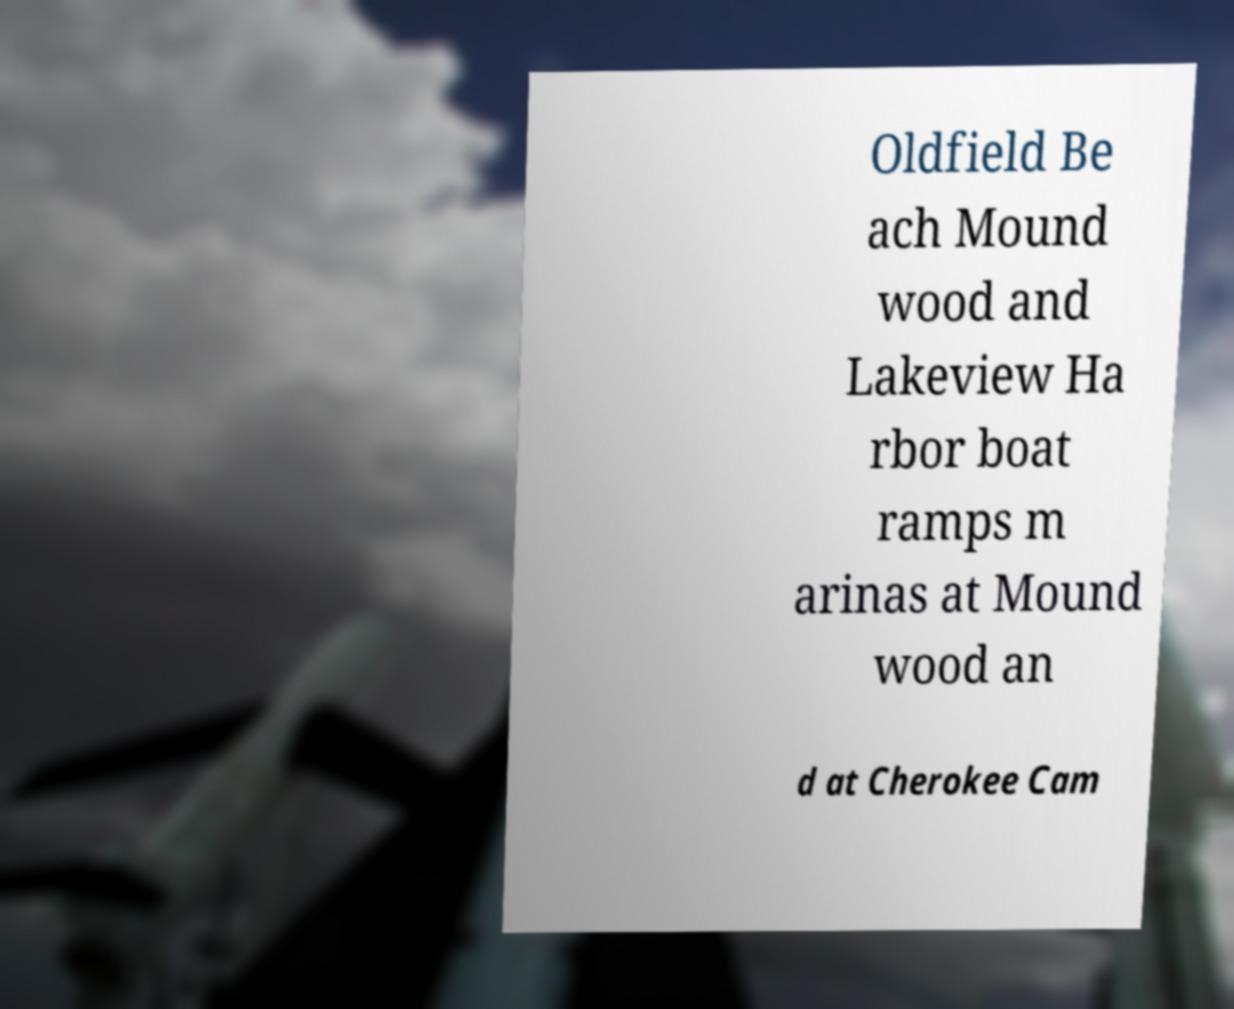Could you extract and type out the text from this image? Oldfield Be ach Mound wood and Lakeview Ha rbor boat ramps m arinas at Mound wood an d at Cherokee Cam 